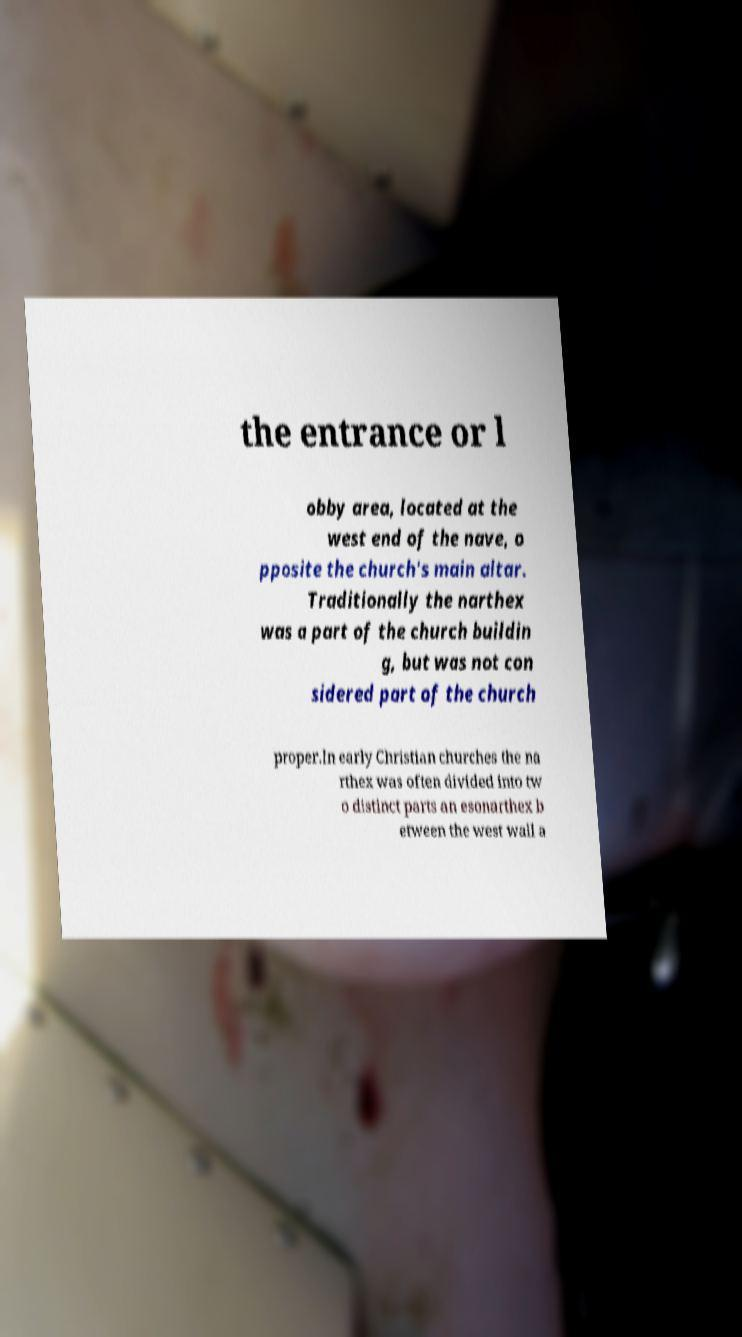Can you accurately transcribe the text from the provided image for me? the entrance or l obby area, located at the west end of the nave, o pposite the church's main altar. Traditionally the narthex was a part of the church buildin g, but was not con sidered part of the church proper.In early Christian churches the na rthex was often divided into tw o distinct parts an esonarthex b etween the west wall a 